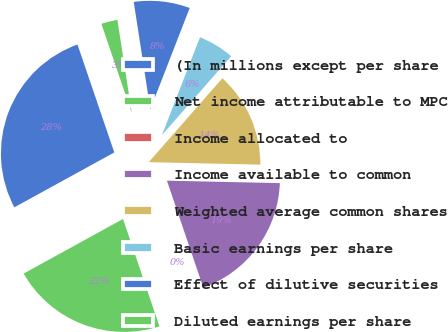Convert chart to OTSL. <chart><loc_0><loc_0><loc_500><loc_500><pie_chart><fcel>(In millions except per share<fcel>Net income attributable to MPC<fcel>Income allocated to<fcel>Income available to common<fcel>Weighted average common shares<fcel>Basic earnings per share<fcel>Effect of dilutive securities<fcel>Diluted earnings per share<nl><fcel>27.76%<fcel>22.21%<fcel>0.01%<fcel>19.44%<fcel>13.89%<fcel>5.56%<fcel>8.34%<fcel>2.79%<nl></chart> 